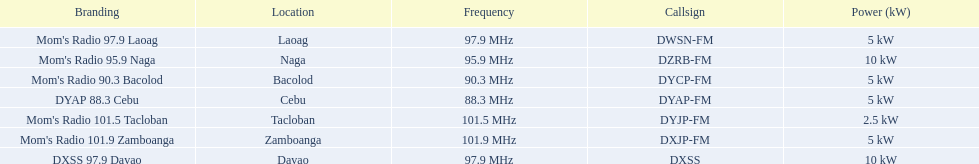How many stations show 5 kw or above in the power column? 6. 